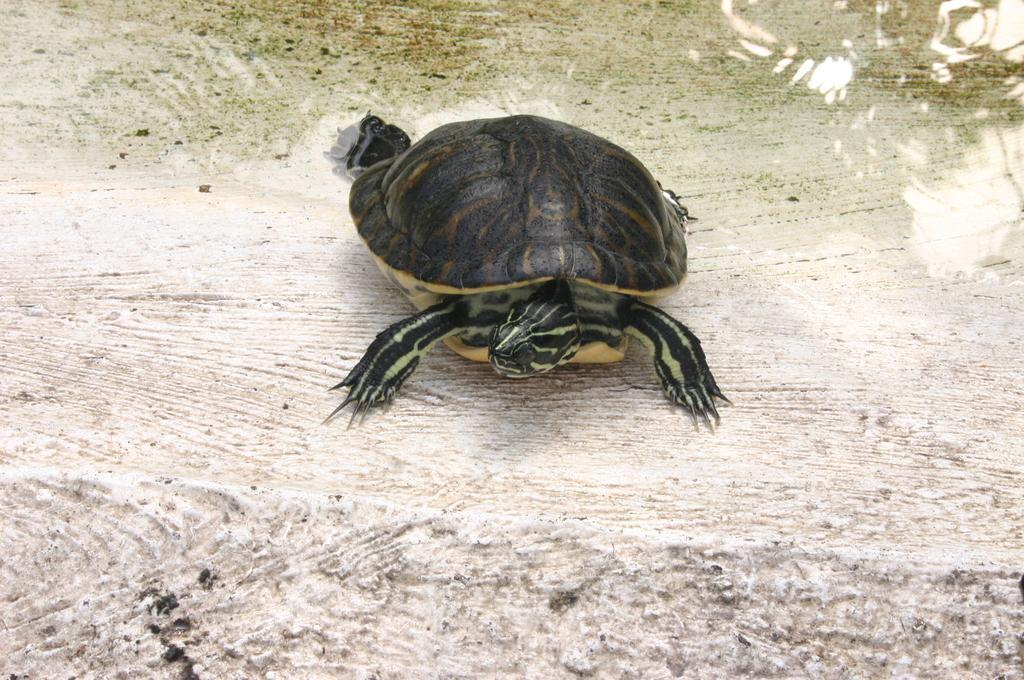Please provide a concise description of this image. In this image there is a tortoise in side water body. This is the head. 